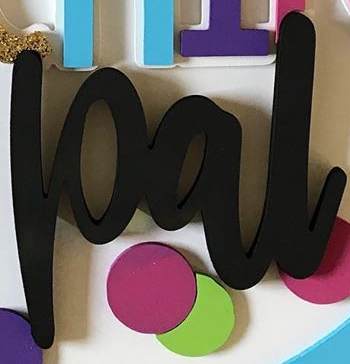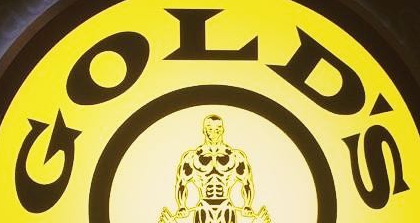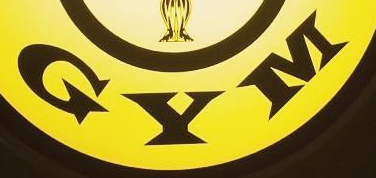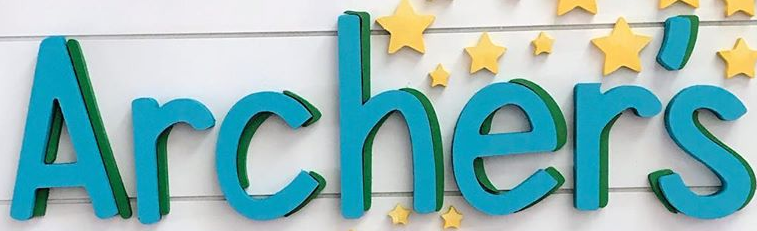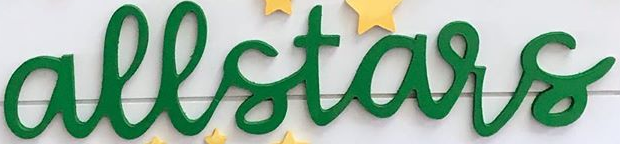Read the text from these images in sequence, separated by a semicolon. pal; GOLD'S; GYM; Archer's; allstars 